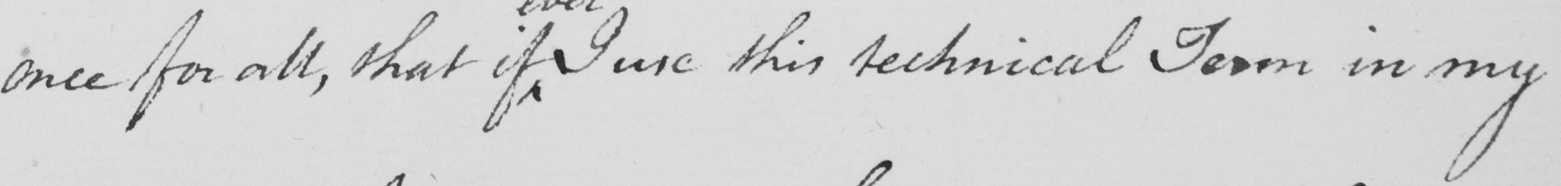Please provide the text content of this handwritten line. once for all , that if I use this technical Term in my 